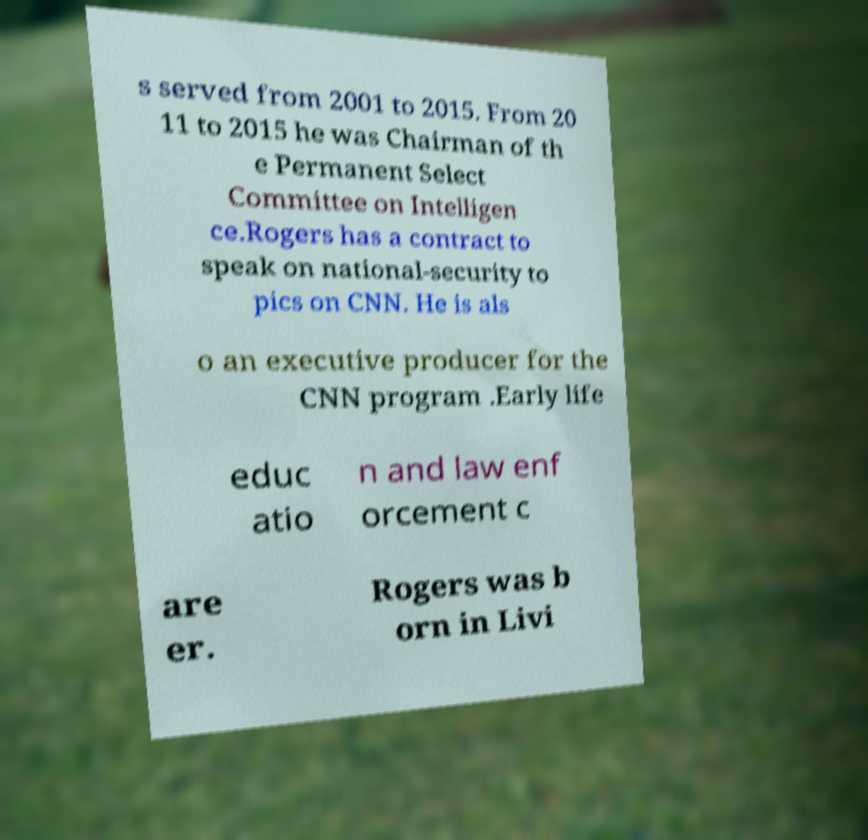I need the written content from this picture converted into text. Can you do that? s served from 2001 to 2015. From 20 11 to 2015 he was Chairman of th e Permanent Select Committee on Intelligen ce.Rogers has a contract to speak on national-security to pics on CNN. He is als o an executive producer for the CNN program .Early life educ atio n and law enf orcement c are er. Rogers was b orn in Livi 